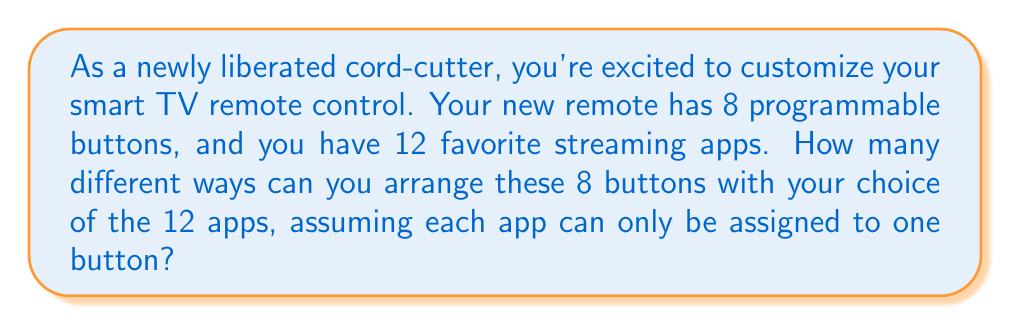Give your solution to this math problem. Let's approach this step-by-step:

1) This is a permutation problem. We are selecting 8 apps out of 12 and arranging them in a specific order on the 8 buttons.

2) The number of ways to select 8 items out of 12, where the order matters, is given by the permutation formula:

   $$P(12,8) = \frac{12!}{(12-8)!} = \frac{12!}{4!}$$

3) Let's calculate this:
   
   $$\frac{12!}{4!} = \frac{12 \times 11 \times 10 \times 9 \times 8!}{4 \times 3 \times 2 \times 1}$$

4) Simplify:
   
   $$= 12 \times 11 \times 10 \times 9 = 11,880$$

5) Therefore, there are 11,880 different ways to arrange 8 out of 12 apps on the programmable buttons.
Answer: 11,880 different configurations 